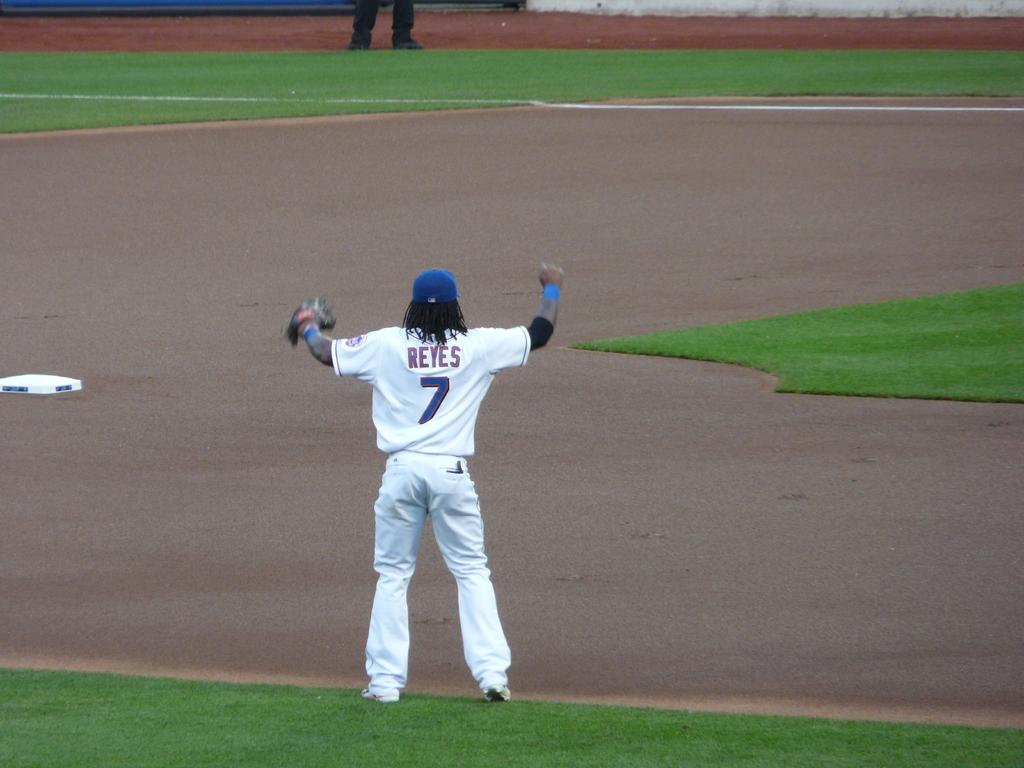<image>
Write a terse but informative summary of the picture. a baseball player whose last name is reyes and wears the number 7 uniform 